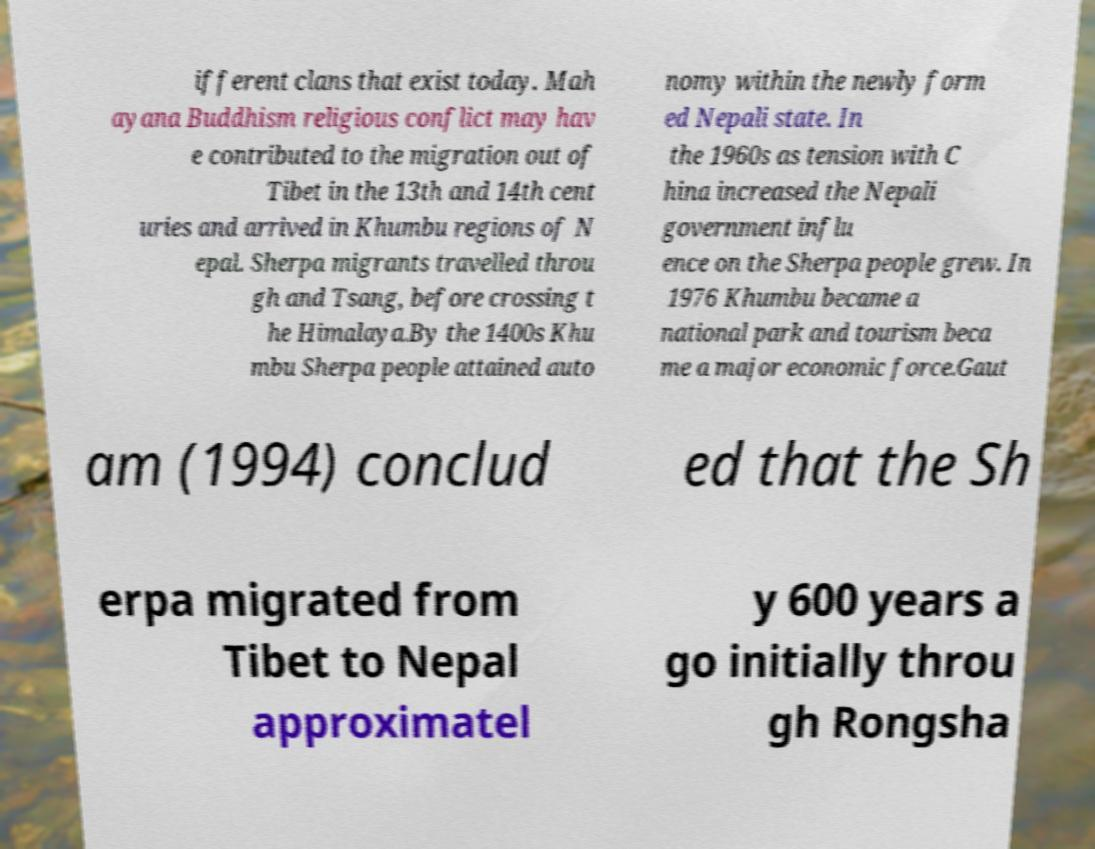What messages or text are displayed in this image? I need them in a readable, typed format. ifferent clans that exist today. Mah ayana Buddhism religious conflict may hav e contributed to the migration out of Tibet in the 13th and 14th cent uries and arrived in Khumbu regions of N epal. Sherpa migrants travelled throu gh and Tsang, before crossing t he Himalaya.By the 1400s Khu mbu Sherpa people attained auto nomy within the newly form ed Nepali state. In the 1960s as tension with C hina increased the Nepali government influ ence on the Sherpa people grew. In 1976 Khumbu became a national park and tourism beca me a major economic force.Gaut am (1994) conclud ed that the Sh erpa migrated from Tibet to Nepal approximatel y 600 years a go initially throu gh Rongsha 